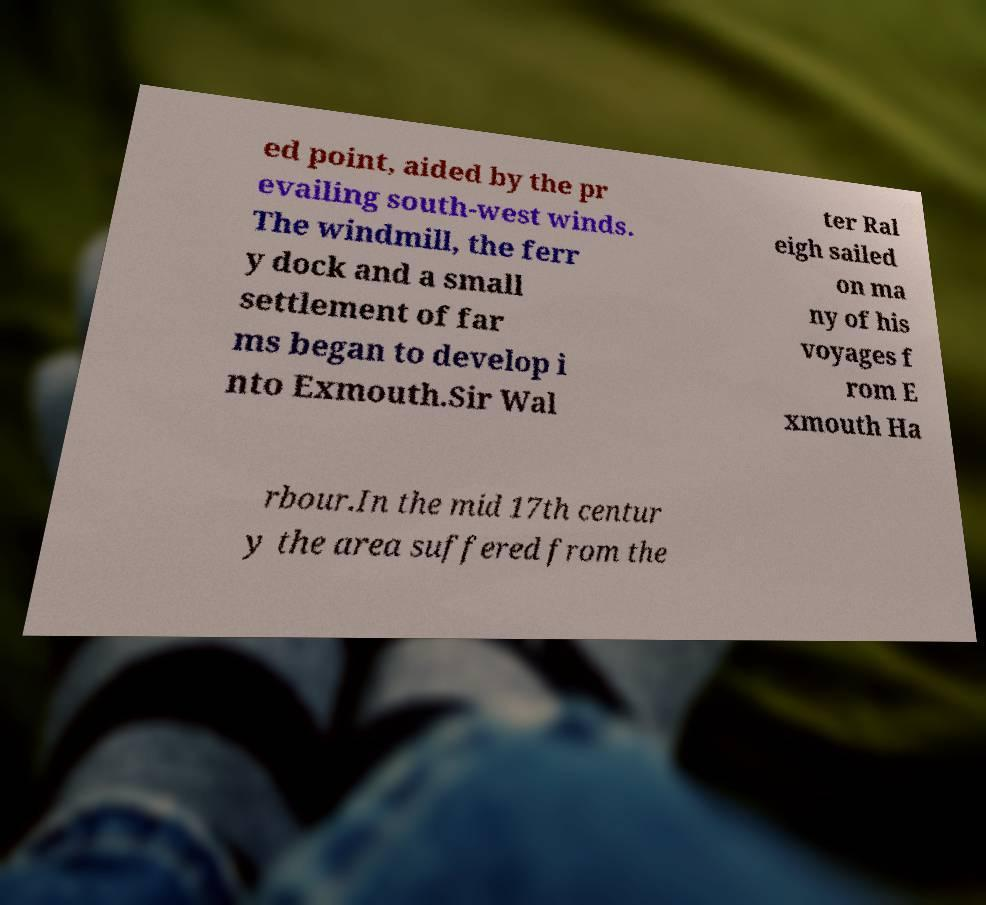Can you read and provide the text displayed in the image?This photo seems to have some interesting text. Can you extract and type it out for me? ed point, aided by the pr evailing south-west winds. The windmill, the ferr y dock and a small settlement of far ms began to develop i nto Exmouth.Sir Wal ter Ral eigh sailed on ma ny of his voyages f rom E xmouth Ha rbour.In the mid 17th centur y the area suffered from the 